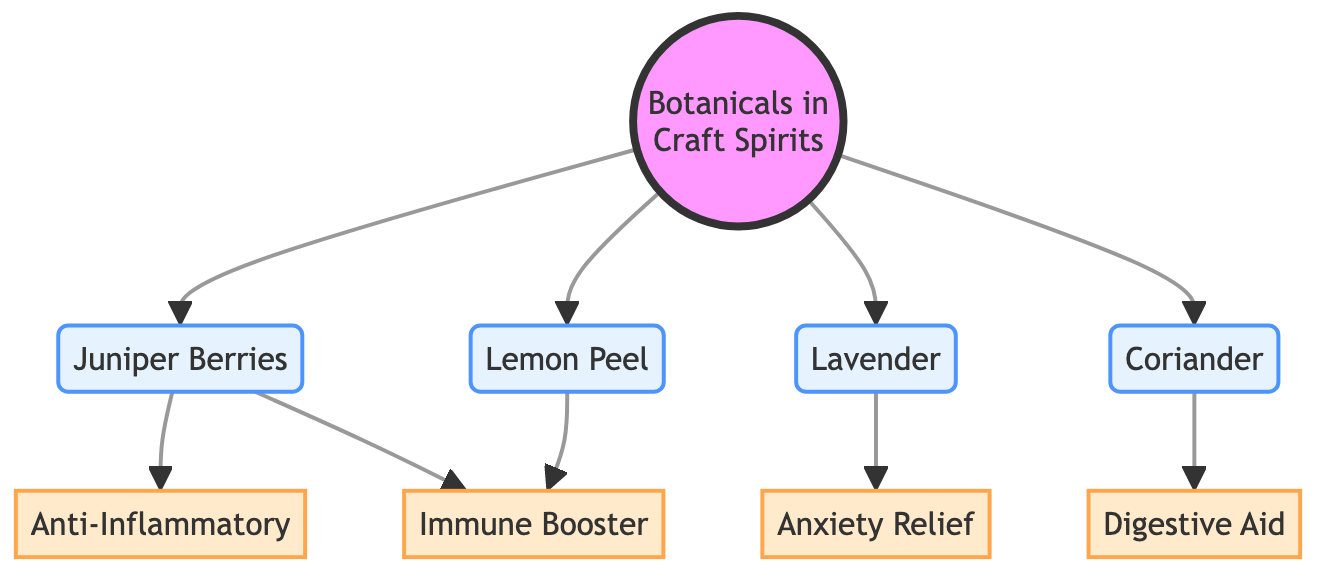What are the botanicals listed in the diagram? The diagram lists four botanicals: Juniper Berries, Lavender, Coriander, and Lemon Peel. This can be identified by looking at the nodes directly connected to the "Botanicals in Craft Spirits" node.
Answer: Juniper Berries, Lavender, Coriander, Lemon Peel How many benefits are shown in the diagram? There are four benefits displayed: Anti-Inflammatory, Anxiety Relief, Digestive Aid, and Immune Booster. Counting these benefits in the diagram provides the total number.
Answer: 4 Which botanical is associated with anxiety relief? Lavender is the botanical linked directly to the "Anxiety Relief" benefit. This relationship can be seen in the diagram through the connecting arrow leading from Lavender to Anxiety Relief.
Answer: Lavender Which two botanicals boost the immune system? Juniper Berries and Lemon Peel are both connected to the "Immune Booster" benefit. This can be confirmed by following the connections leading to the Immune Booster node from both Juniper Berries and Lemon Peel.
Answer: Juniper Berries and Lemon Peel What is the relationship between Juniper Berries and Anti-Inflammatory? Juniper Berries have a direct connection to the "Anti-Inflammatory" benefit, indicating that they are associated with this health effect. By examining the diagram's flow, we identify that the arrow from Juniper Berries directly points to this benefit node.
Answer: Anti-Inflammatory Which botanical is linked to digestive aid? Coriander is the botanical that connects to the "Digestive Aid" benefit in the diagram, signified by a direct arrow from Coriander to the corresponding benefit.
Answer: Coriander How many botanicals provide immune-boosting benefits? Two botanicals, Juniper Berries and Lemon Peel, are indicated in the diagram as having connections to the "Immune Booster" benefit, thus counted together, giving the total number of botanicals providing this benefit.
Answer: 2 What type of diagram is this? This is a flowchart diagram, characterized by its use of nodes and connections to depict relationships between various components, specifically illustrating the effects of botanicals on health.
Answer: Flowchart 